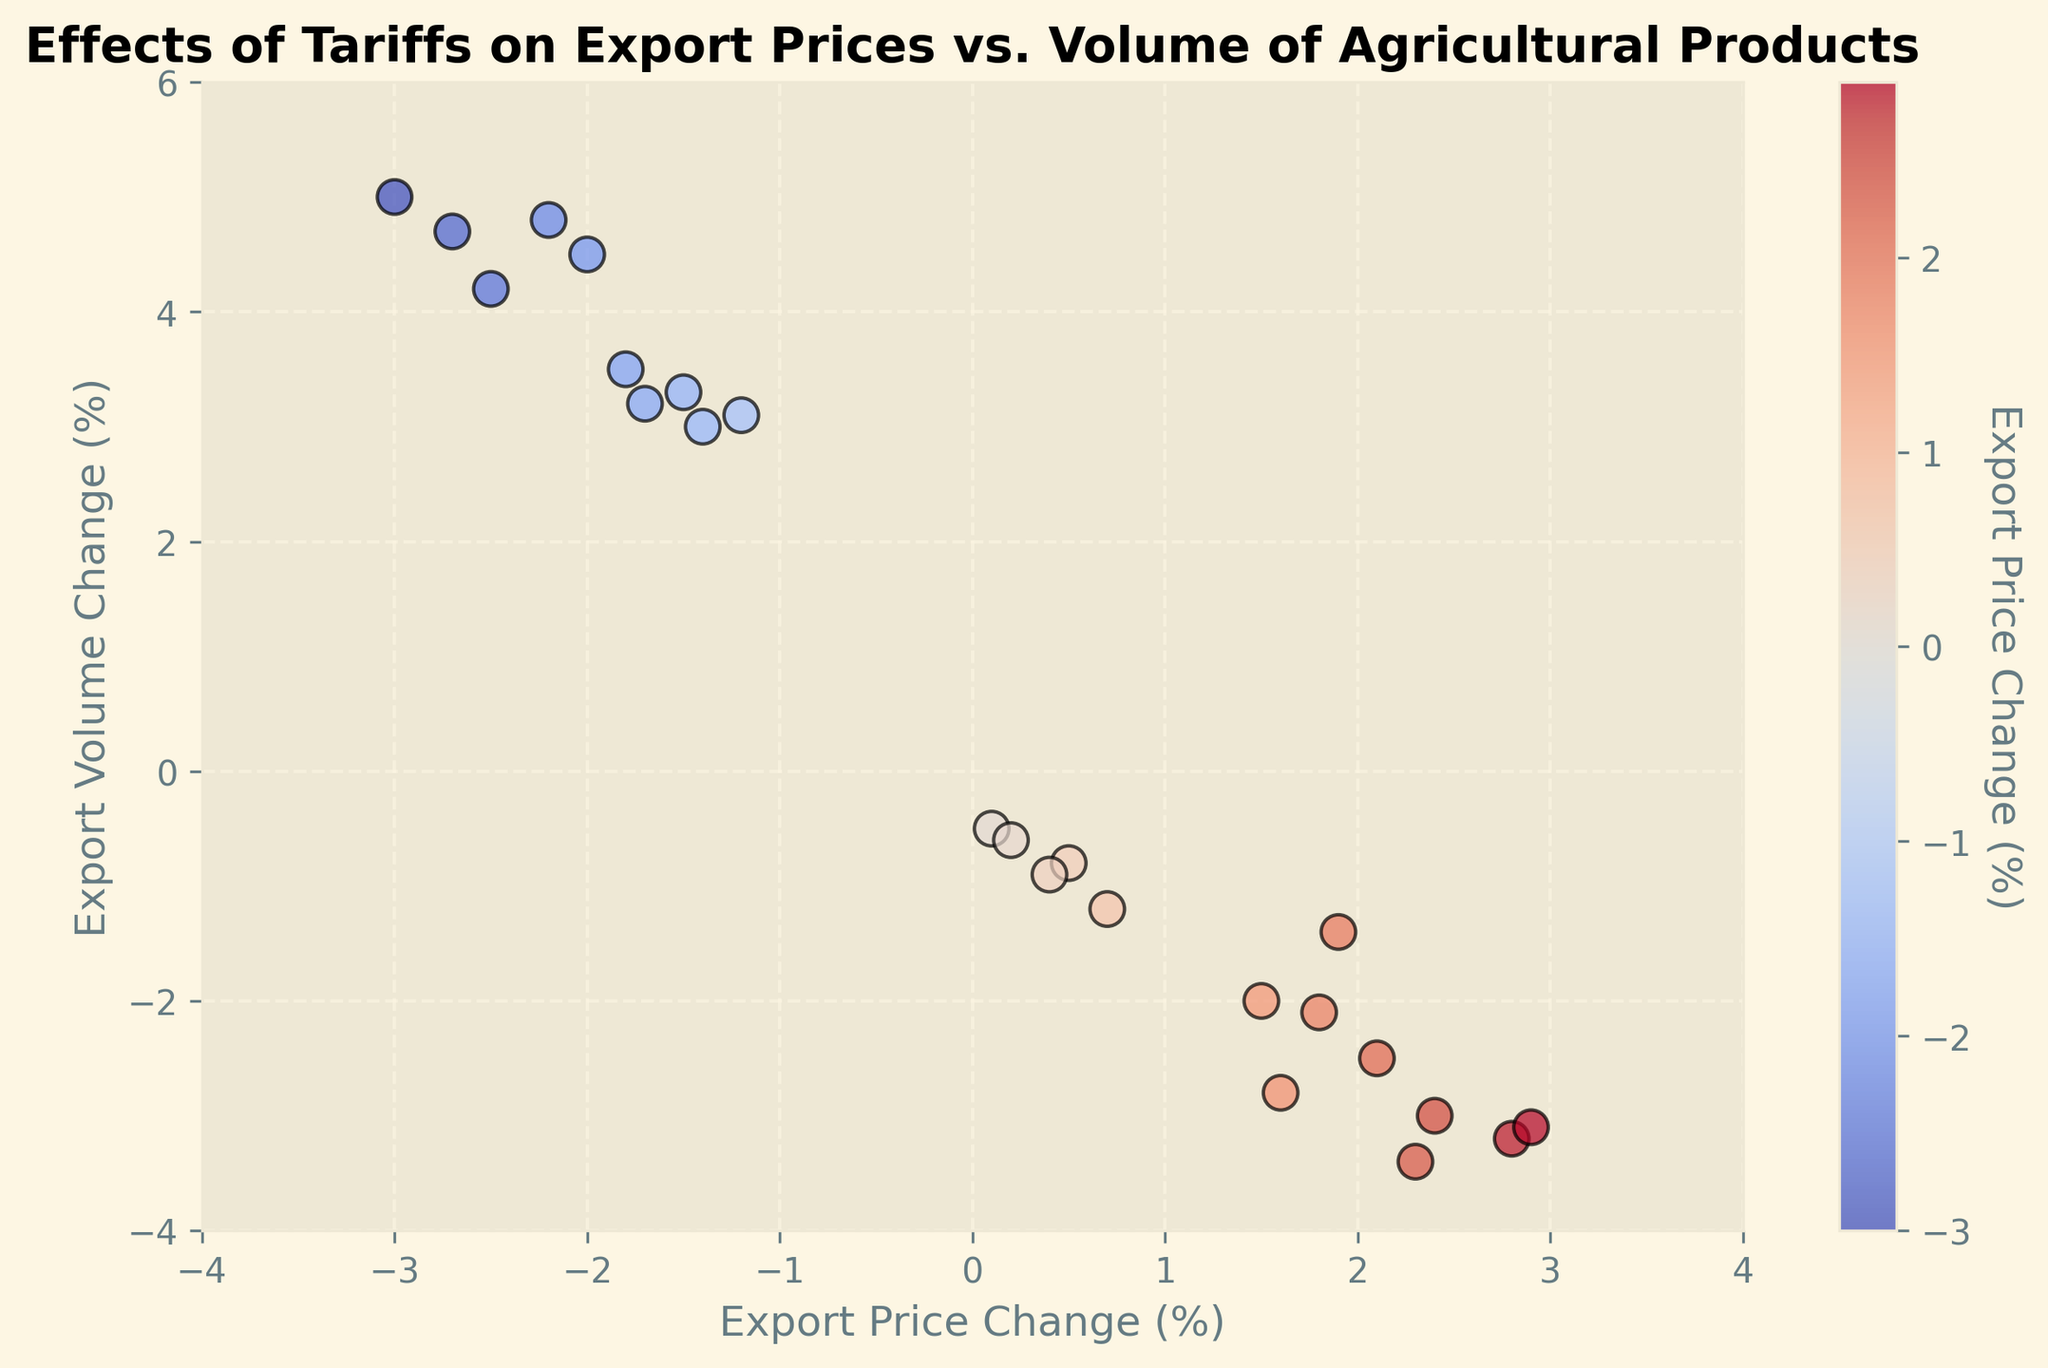What's the average change in export prices for the positive changes? To calculate the average, sum all the positive Export_Price_Change values (0.1, 1.5, 2.3, 0.5, 1.8, 2.4, 0.2, 1.9, 2.8, 0.4, 2.1, 2.9, 0.7, 1.6) which totals 21.2. Then divide by the number of positive changes, which is 14. Thus, the average is 21.2 / 14 ≈ 1.51.
Answer: 1.51 Which month had the highest export volume change? The highest export volume change is 5.0% in November 2018.
Answer: November 2018 Is there any month where both export price change and export volume change are negative? We need to look for data points where both the Export_Price_Change and Export_Volume_Change values are negative. This occurs in March 2018, April 2018, May 2018, August 2018, September 2018, October 2018, January 2019, February 2019, March 2019, July 2019, August 2019, November 2019.
Answer: Yes Which months had a decrease in export price but an increase in export volume? We need to check the data where Export_Price_Change is negative and Export_Volume_Change is positive. These months are January 2018, February 2018, June 2018, July 2018, November 2018, December 2018, April 2019, May 2019, September 2019, and October 2019.
Answer: January 2018, February 2018, June 2018, July 2018, November 2018, December 2018, April 2019, May 2019, September 2019, October 2019 Is there a trend between export price change and export volume change? To observe a trend, one would need to examine if there's a consistent pattern in the scatter plot. However, visually, the plot does not suggest a clear linear relationship. Sometimes, as prices go up, volumes decrease, and vice versa, indicating an inverse relationship.
Answer: No clear linear trend What is the general visual correlation between export price change and export volume change? By observing the scatter plot, the general visual trend (if any) seems to be that as export prices increase, export volumes tend to decrease, and when export prices decrease, export volumes tend to increase, suggesting a possible inverse correlation.
Answer: Inverse correlation Which color indicates the highest export price changes? In the scatter plot, the highest export price changes are indicated by the intensity of red on the color gradient.
Answer: Red 